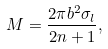Convert formula to latex. <formula><loc_0><loc_0><loc_500><loc_500>M = \frac { 2 \pi b ^ { 2 } \sigma _ { l } } { 2 n + 1 } ,</formula> 